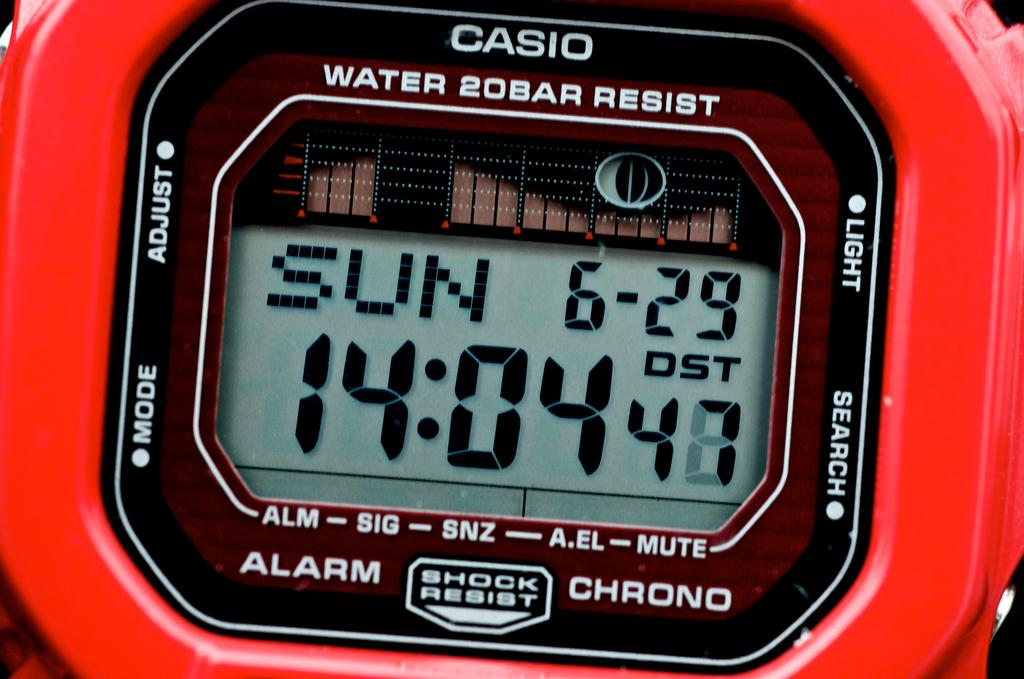<image>
Describe the image concisely. A digital clock is printed with the words "WATER 20BAR RESIST". 